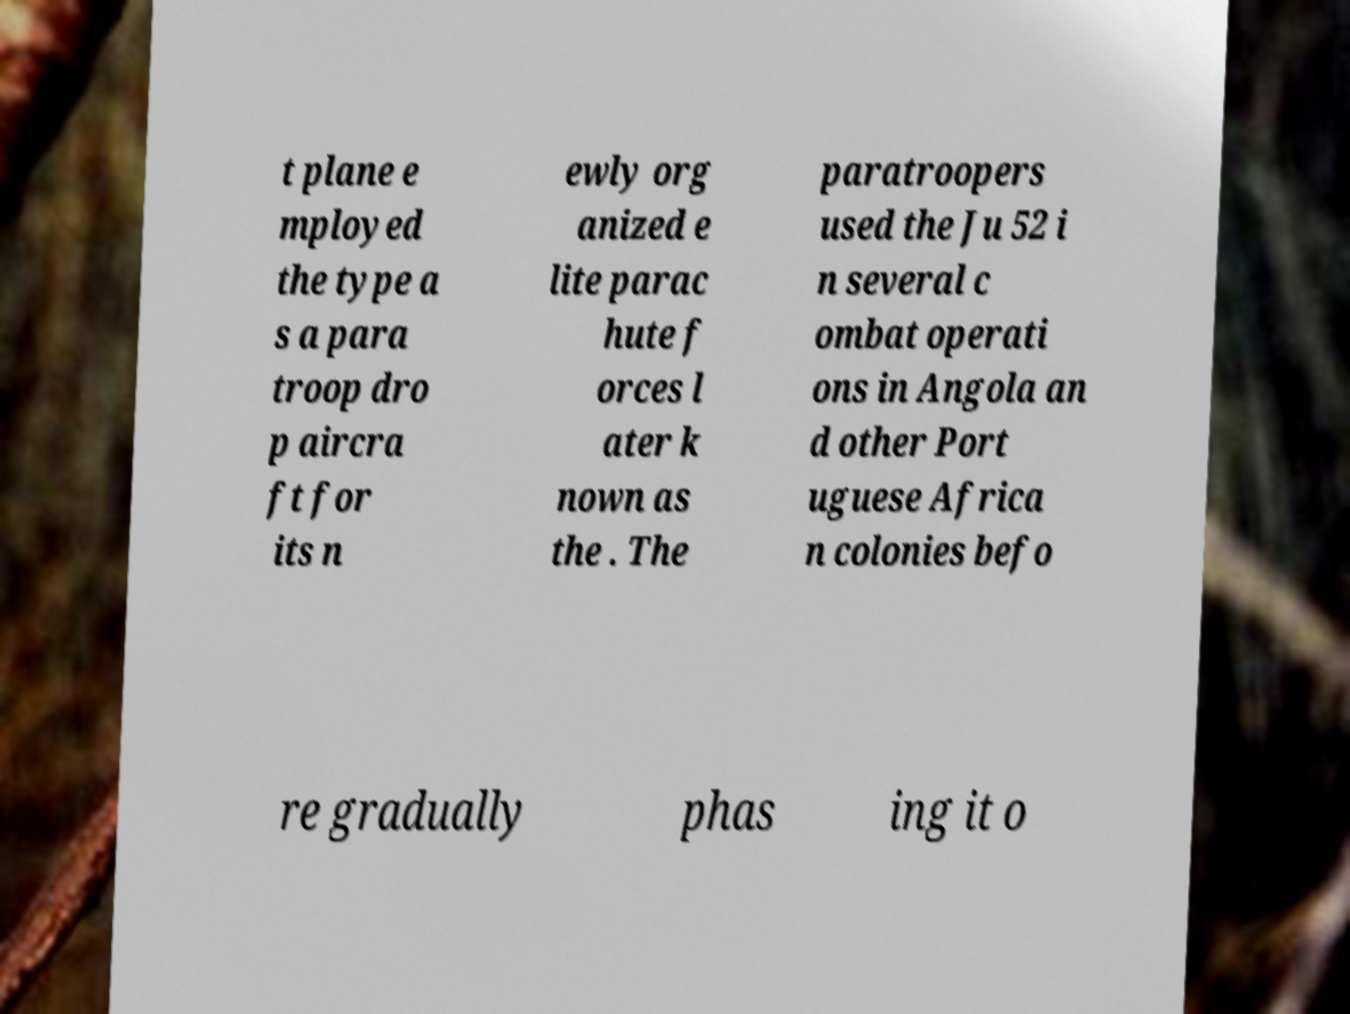Can you accurately transcribe the text from the provided image for me? t plane e mployed the type a s a para troop dro p aircra ft for its n ewly org anized e lite parac hute f orces l ater k nown as the . The paratroopers used the Ju 52 i n several c ombat operati ons in Angola an d other Port uguese Africa n colonies befo re gradually phas ing it o 